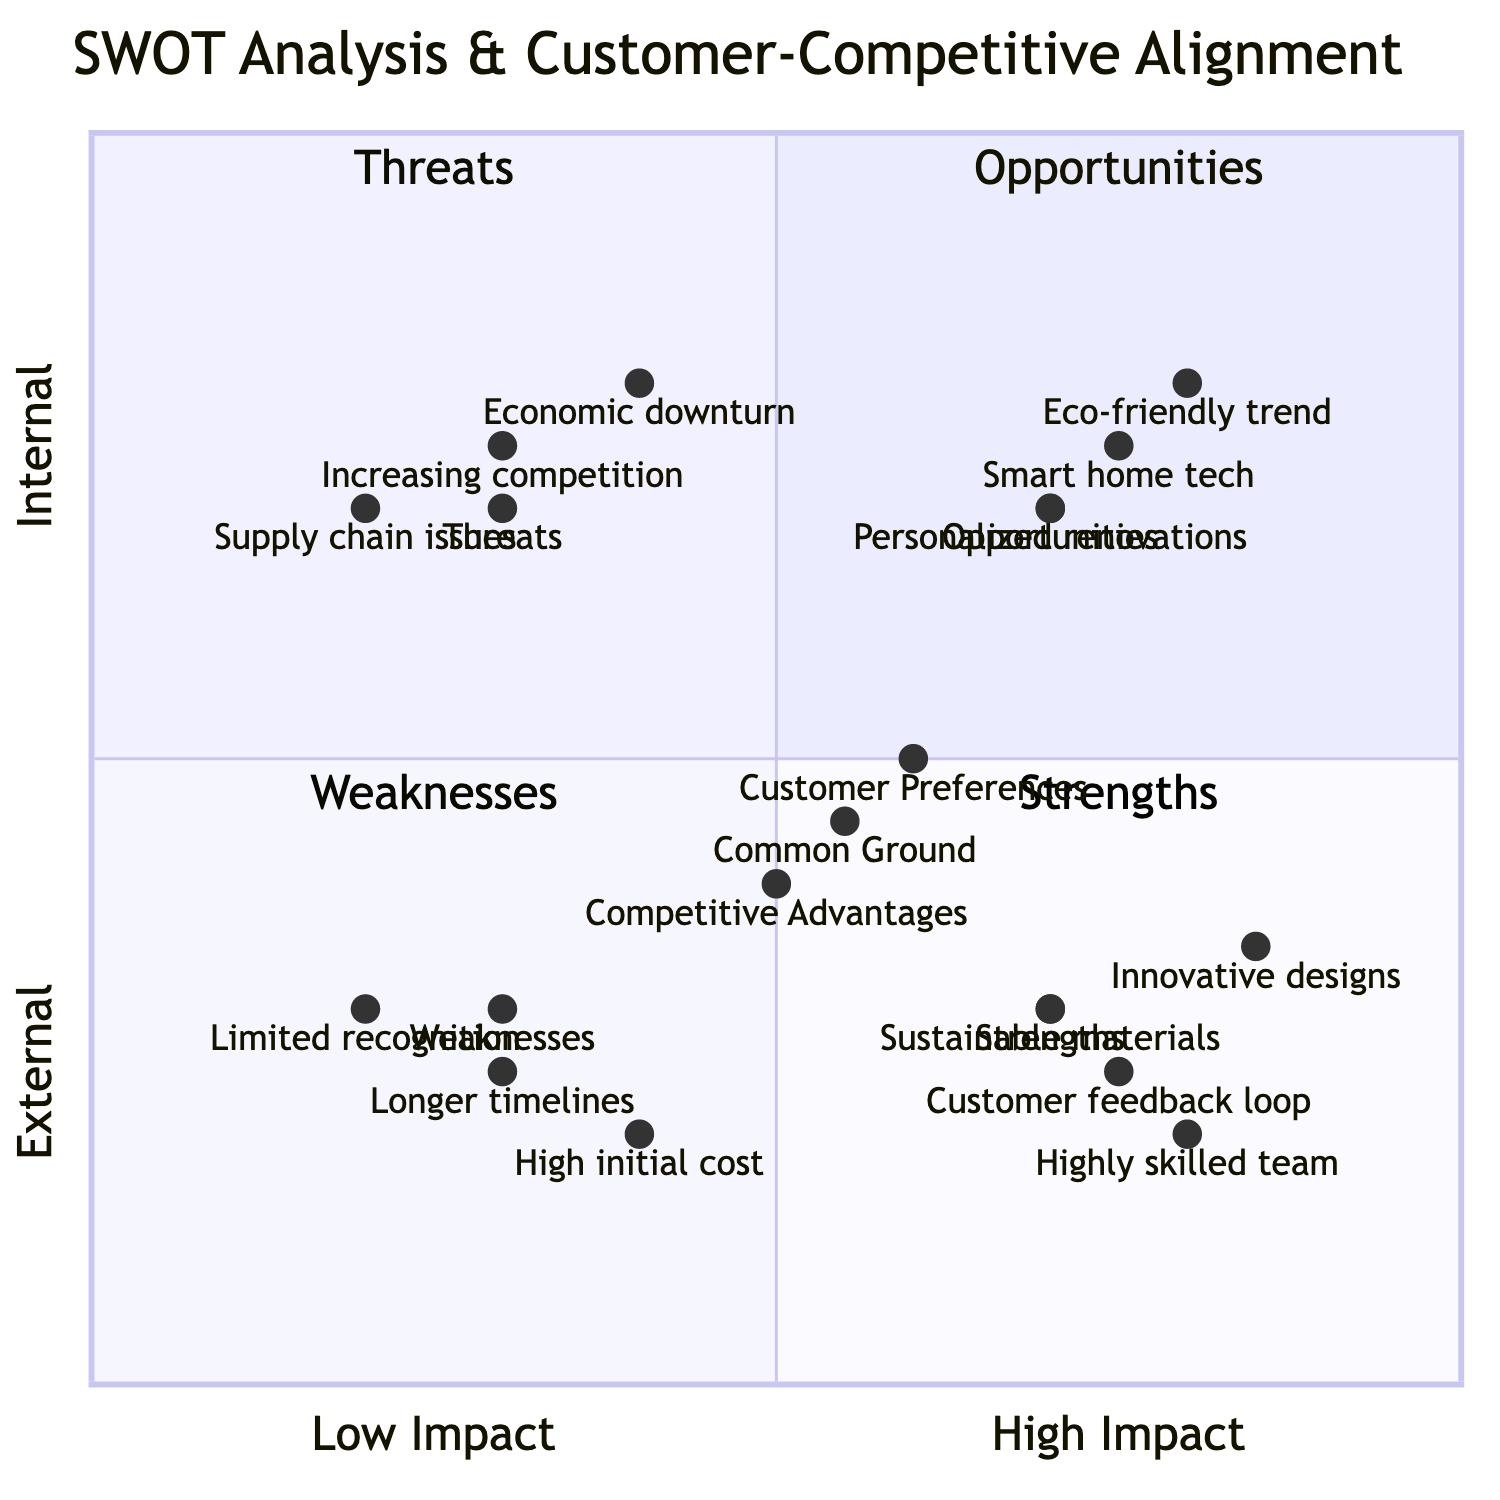What is the y-coordinate of "Customer feedback loop"? Looking at the diagram, the node "Customer feedback loop" has coordinates [0.75, 0.25]. The second value represents the y-coordinate, which is 0.25.
Answer: 0.25 Which quadrant contains the "High initial cost" factor? The "High initial cost" factor has coordinates [0.4, 0.2]. Referencing the quadrant definitions, this point falls in quadrant 3, which represents Weaknesses.
Answer: Weaknesses What is the common ground value in the Venn diagram? The "Common Ground" in the Venn diagram is represented by the coordinates [0.55, 0.45]. The first value indicates its position on the x-axis.
Answer: [0.55, 0.45] Identify the main strength that has the highest x-value. The strength that has the highest x-value is "Innovative designs," which has coordinates of [0.85, 0.35]. The first coordinate (x-value) is the highest among the strengths listed.
Answer: Innovative designs How many nodes represent opportunities in the SWOT analysis? In the SWOT analysis, there are three opportunities shown as nodes based on their coordinates and placement. The nodes listed include "Eco-friendly trend," "Smart home tech," and "Personalized renovations."
Answer: 3 Which element has the closest position to the upper right corner of the diagram? The closest element to the upper right corner, which indicates high impact and external categorization, is "Eco-friendly trend" located at [0.8, 0.8]. It has the y-coordinate value of 0.8, the highest indicating it is in the upper area of the chart.
Answer: Eco-friendly trend What is the relationship between "Customer Preferences" and "Competitive Advantages"? The "Customer Preferences" and "Competitive Advantages" nodes have coordinates [0.6, 0.5] and [0.5, 0.4], respectively. Analyzing their positions, you can see they are relatively close but with "Customer Preferences" having a slightly higher x and y value showing preference in terms of alignment.
Answer: Close but distinct Which quadrant does "Longer timelines" fall into? "Longer timelines" has coordinates [0.3, 0.25]. From the quadrant definitions, this point falls in quadrant 3, which represents Weaknesses, due to its low impact and internal focus.
Answer: Weaknesses 